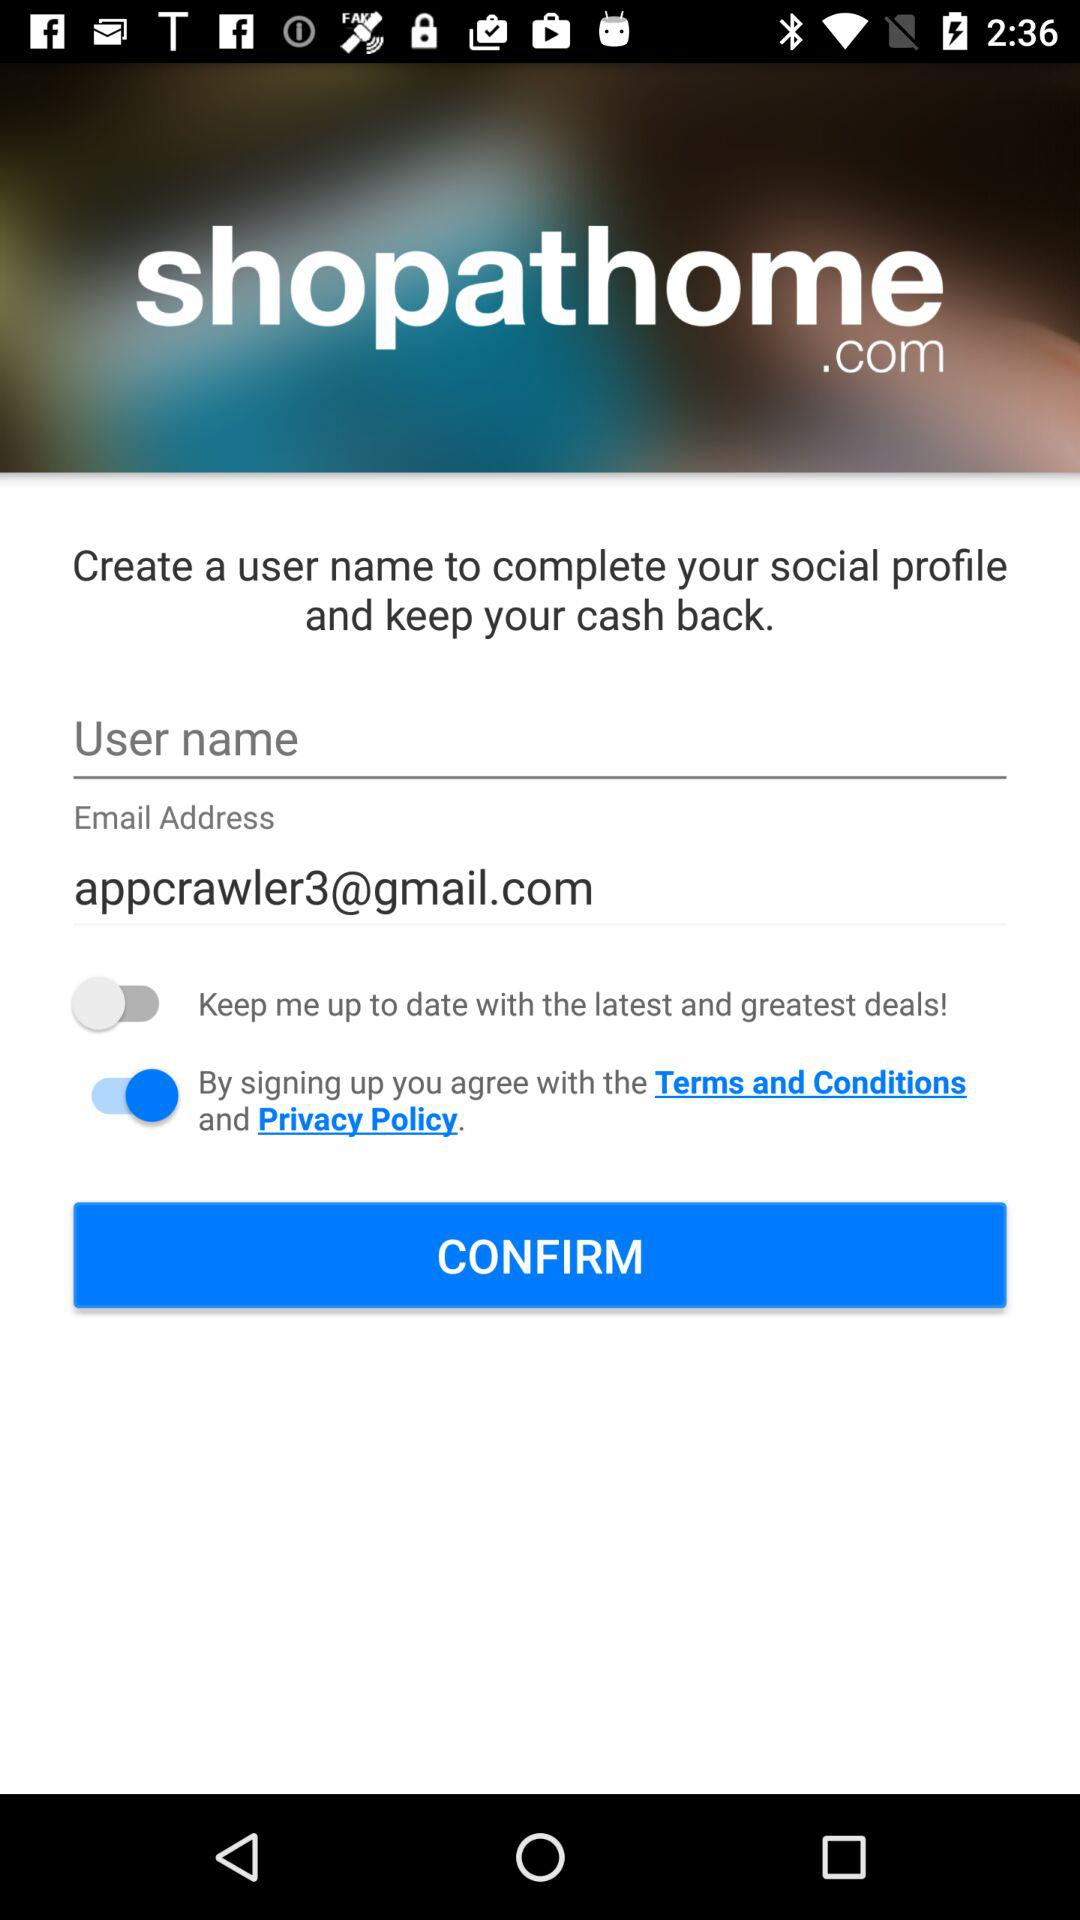What is the application name? The application name is "shopathome". 